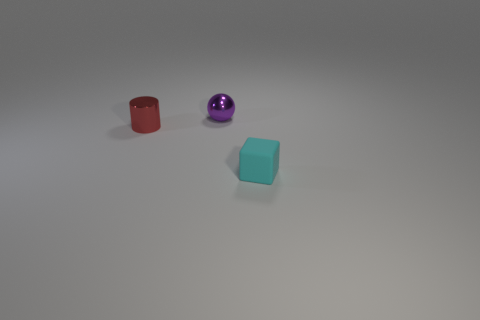Add 1 purple balls. How many objects exist? 4 Subtract all blocks. How many objects are left? 2 Add 3 small purple things. How many small purple things are left? 4 Add 3 tiny red metallic things. How many tiny red metallic things exist? 4 Subtract 0 purple cylinders. How many objects are left? 3 Subtract all cyan objects. Subtract all red objects. How many objects are left? 1 